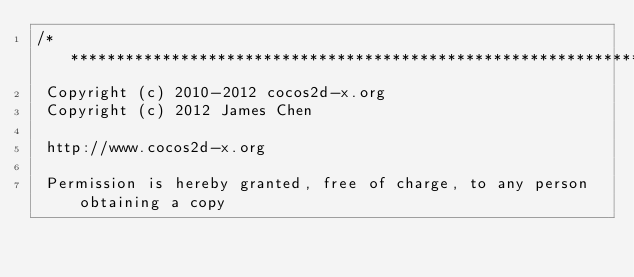Convert code to text. <code><loc_0><loc_0><loc_500><loc_500><_ObjectiveC_>/****************************************************************************
 Copyright (c) 2010-2012 cocos2d-x.org
 Copyright (c) 2012 James Chen
 
 http://www.cocos2d-x.org
 
 Permission is hereby granted, free of charge, to any person obtaining a copy</code> 